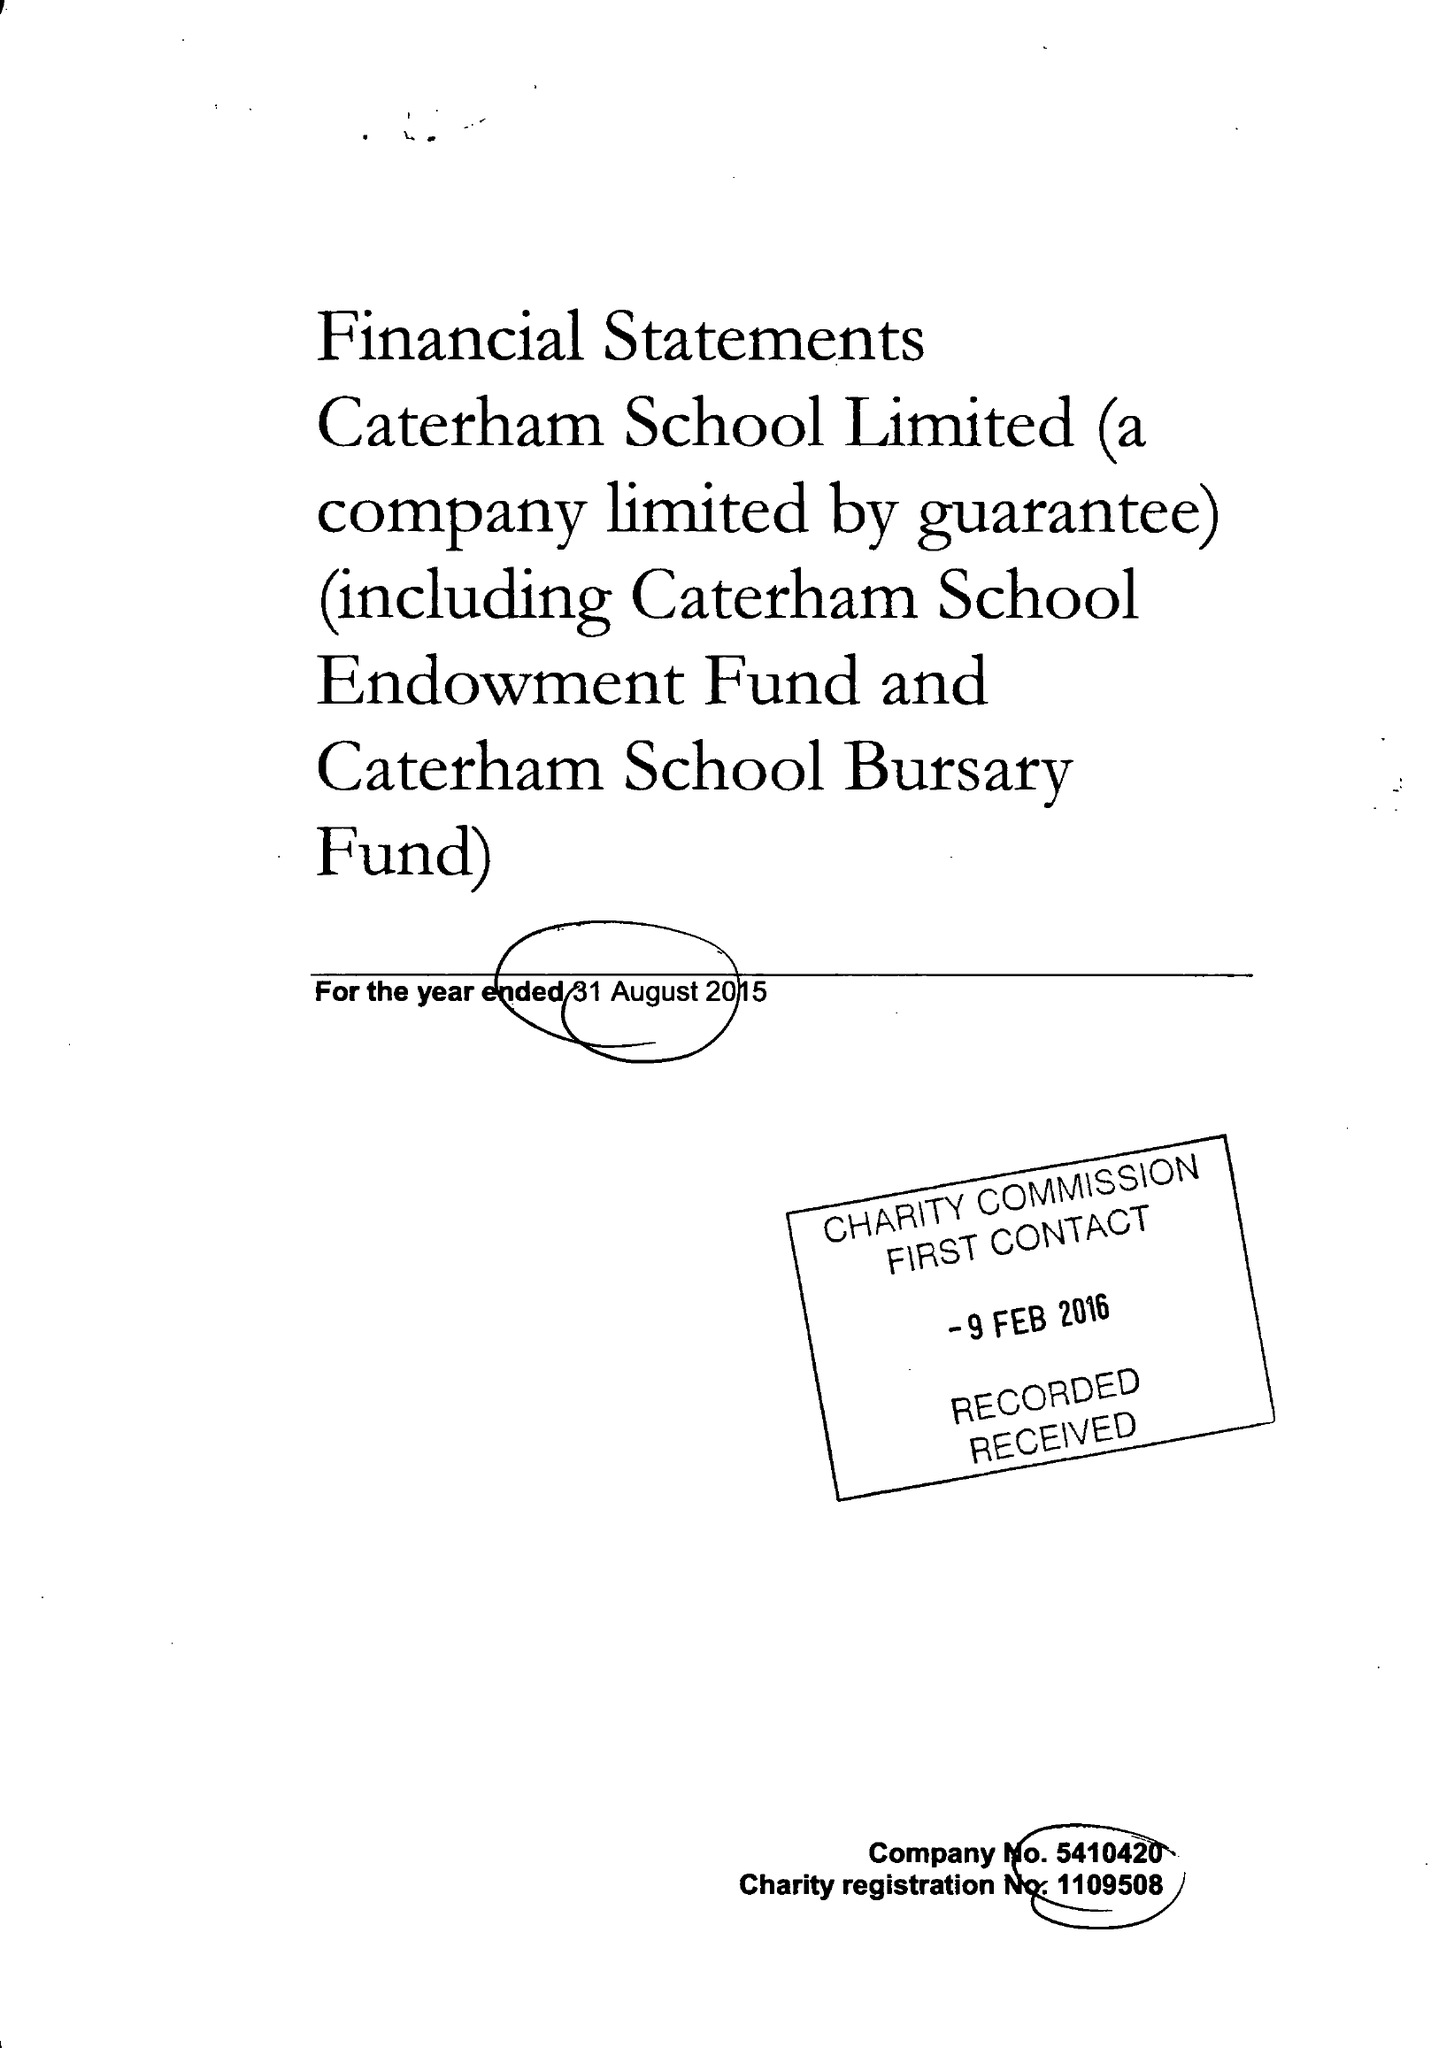What is the value for the address__post_town?
Answer the question using a single word or phrase. WHYTELEAFE 